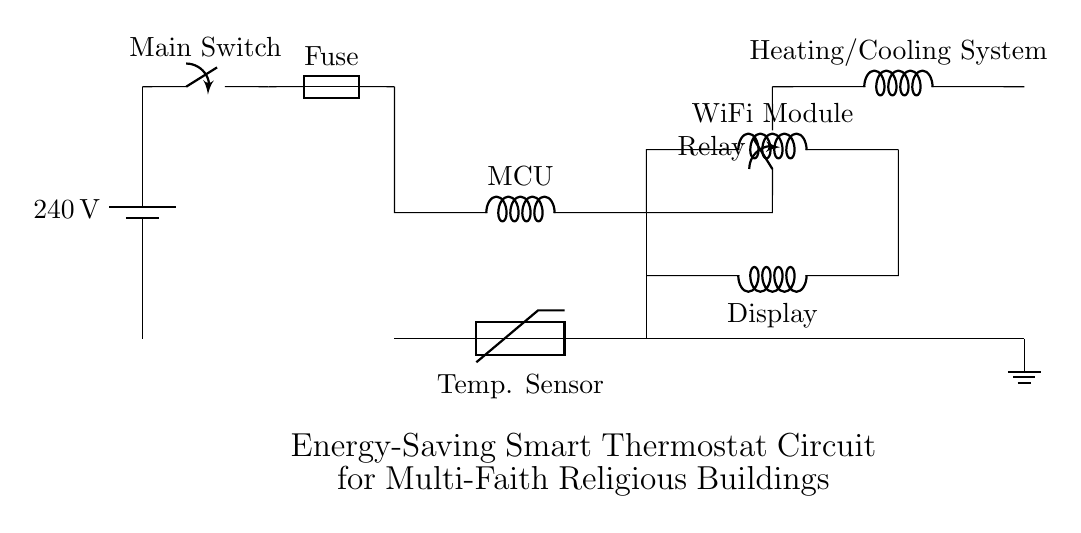What is the voltage of the power supply in this circuit? The voltage is specified near the battery symbol, indicated as 240 volts.
Answer: 240 volts What component is used to measure temperature? The temperature sensor is labeled as a thermistor in the circuit, showing its role in measuring temperature.
Answer: Thermistor What is the function of the relay in this circuit? The relay is represented as a closing switch and is responsible for controlling the power to the heating and cooling system based on the signals from the microcontroller.
Answer: Power control What type of system is connected to the output of the relay? The circuit shows that the output of the relay is connected to the heating and cooling system, indicating it allows control over climate control equipment.
Answer: Heating and cooling system How many main components are directly connected to the microcontroller? There are three components directly connected to the microcontroller: the temperature sensor, the relay, and the WiFi module, each serving distinct functions in regulation and communication.
Answer: Three What type of communication module is included in this circuit? The communication module is identified as a WiFi module, which allows the smart thermostat to connect to wireless networks for smart home integration.
Answer: WiFi module What is the purpose of the fuse in this circuit? The fuse is included in the circuit for protection, serving as a safety device that prevents overcurrent by melting if the current flow exceeds a certain level.
Answer: Overcurrent protection 